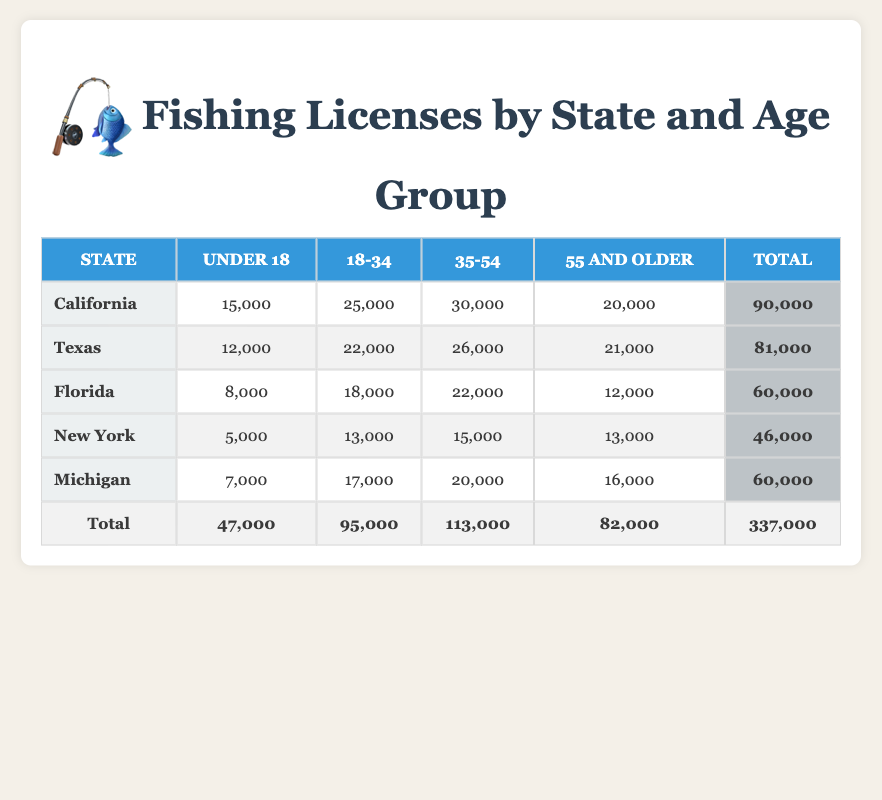What state issued the highest number of fishing licenses in the age group 35-54? The table shows that California issued 30,000 licenses in the age group 35-54, the highest of all the states listed. Other states like Texas issued 26,000, Florida issued 22,000, New York issued 15,000, and Michigan issued 20,000, which are all lower than California's figure.
Answer: California How many total fishing licenses were issued to individuals under 18 across all states? To find this, I sum the values in the "Under 18" column: California (15,000) + Texas (12,000) + Florida (8,000) + New York (5,000) + Michigan (7,000) = 47,000.
Answer: 47,000 Is it true that Florida issued more licenses to the 18-34 age group than Michigan? In the table, Florida issued 18,000 licenses to the 18-34 age group, while Michigan issued 17,000. Since 18,000 is greater than 17,000, the statement is true.
Answer: Yes What is the difference in the number of licenses issued to the 55 and older age group between Texas and Florida? The difference can be calculated by subtracting Florida's total for the 55 and older age group (12,000) from Texas's total (21,000): 21,000 - 12,000 = 9,000. Thus, Texas issued 9,000 more licenses than Florida to that age group.
Answer: 9,000 Which age group had the least total number of licenses issued across all states? First, I add up the totals for each age group: Under 18 (47,000), 18-34 (95,000), 35-54 (113,000), and 55 and older (82,000). The least number corresponds to the "Under 18" group with 47,000 licenses issued overall.
Answer: Under 18 